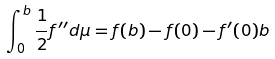<formula> <loc_0><loc_0><loc_500><loc_500>\int _ { 0 } ^ { b } \frac { 1 } { 2 } f ^ { \prime \prime } d \mu = f ( b ) - f ( 0 ) - f ^ { \prime } ( 0 ) b</formula> 